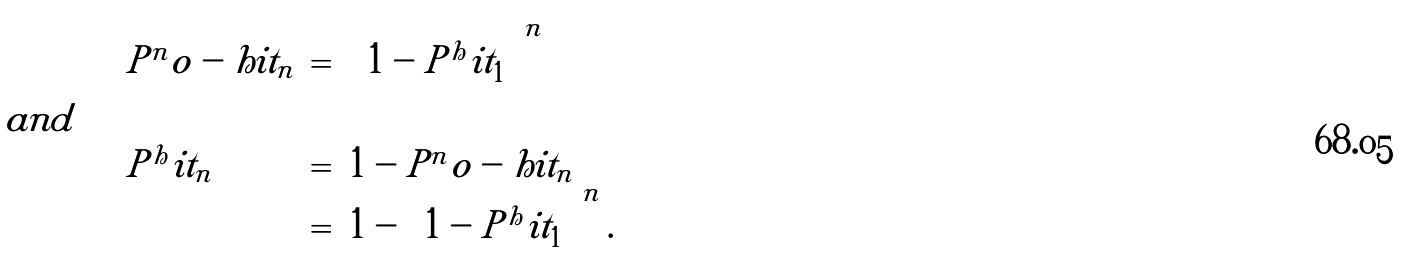Convert formula to latex. <formula><loc_0><loc_0><loc_500><loc_500>\begin{array} { l l c l } & P ^ { n } o - h i t _ { n } & = & \left ( 1 - P ^ { h } i t _ { 1 } \right ) ^ { n } \\ a n d \quad & & & \\ & P ^ { h } i t _ { n } & = & 1 - P ^ { n } o - h i t _ { n } \\ & & = & 1 - \left ( 1 - P ^ { h } i t _ { 1 } \right ) ^ { n } . \end{array}</formula> 